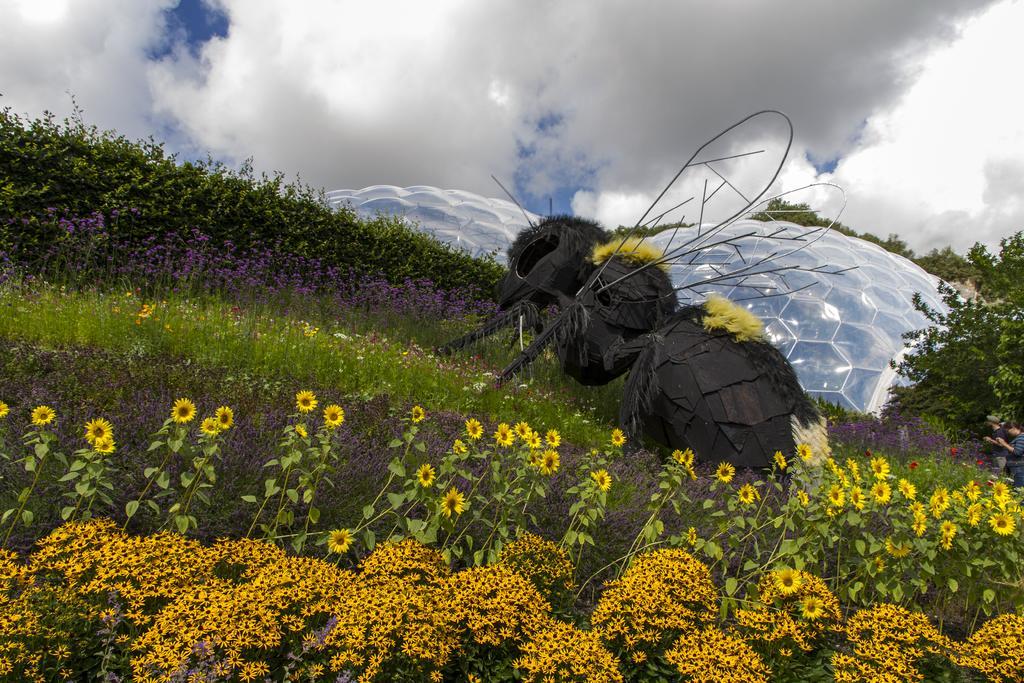Can you describe this image briefly? In this picture there are few flowers which are in yellow color and there is an object in between it and there are few flowers and plants in the background and there are few trees and two persons in the right corner and the sky is cloudy. 